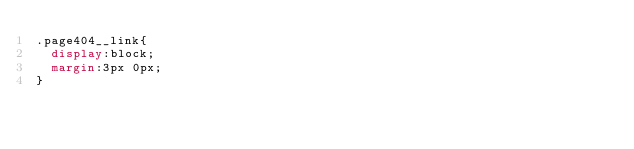Convert code to text. <code><loc_0><loc_0><loc_500><loc_500><_CSS_>.page404__link{
  display:block;
  margin:3px 0px;
}
</code> 